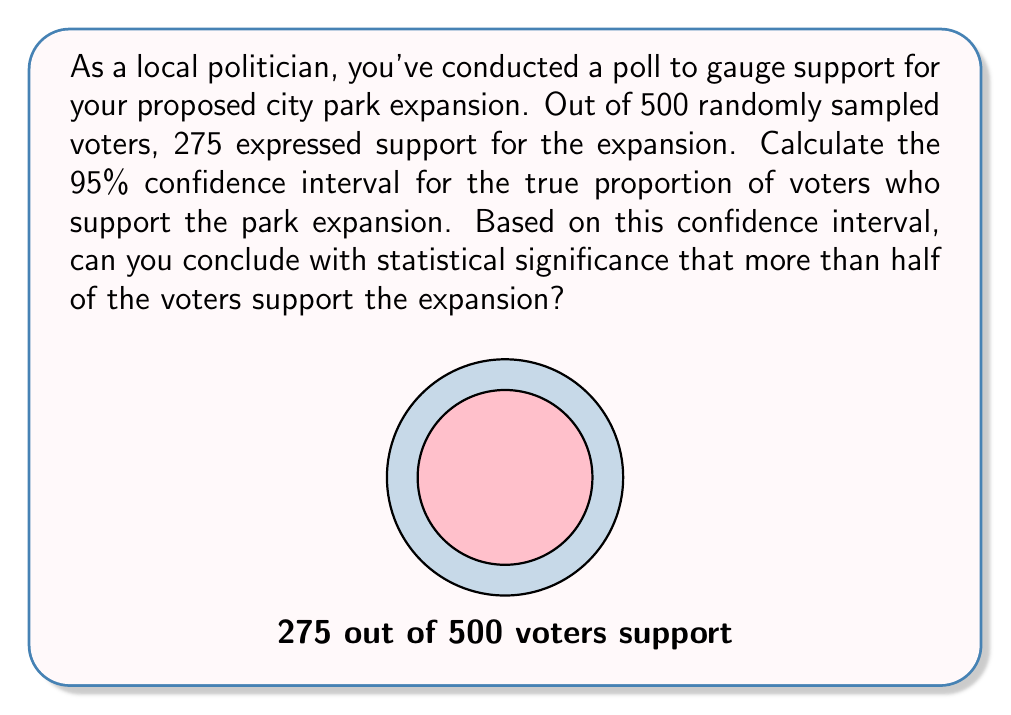Can you answer this question? Let's approach this step-by-step:

1) First, we need to calculate the sample proportion:
   $\hat{p} = \frac{275}{500} = 0.55$ or 55%

2) For a 95% confidence interval, we use a z-score of 1.96.

3) The formula for the margin of error (MOE) is:
   $MOE = z \sqrt{\frac{\hat{p}(1-\hat{p})}{n}}$

   Where:
   $z = 1.96$ (for 95% confidence)
   $\hat{p} = 0.55$
   $n = 500$

4) Let's calculate the MOE:
   $MOE = 1.96 \sqrt{\frac{0.55(1-0.55)}{500}}$
   $= 1.96 \sqrt{\frac{0.2475}{500}}$
   $= 1.96 \sqrt{0.000495}$
   $= 1.96 * 0.02225$
   $= 0.04361$ or about 4.36%

5) The confidence interval is calculated as:
   $\hat{p} \pm MOE$
   $0.55 \pm 0.04361$

   Lower bound: $0.55 - 0.04361 = 0.50639$ or about 50.64%
   Upper bound: $0.55 + 0.04361 = 0.59361$ or about 59.36%

6) To determine statistical significance, we check if the entire confidence interval is above 50%:
   The lower bound (50.64%) is just slightly above 50%.

Therefore, we can conclude with 95% confidence that the true proportion of voters who support the park expansion is between 50.64% and 59.36%. Since the entire interval is above 50%, we can say with statistical significance that more than half of the voters support the expansion, albeit by a narrow margin.
Answer: Yes, statistically significant support (CI: 50.64% - 59.36%) 